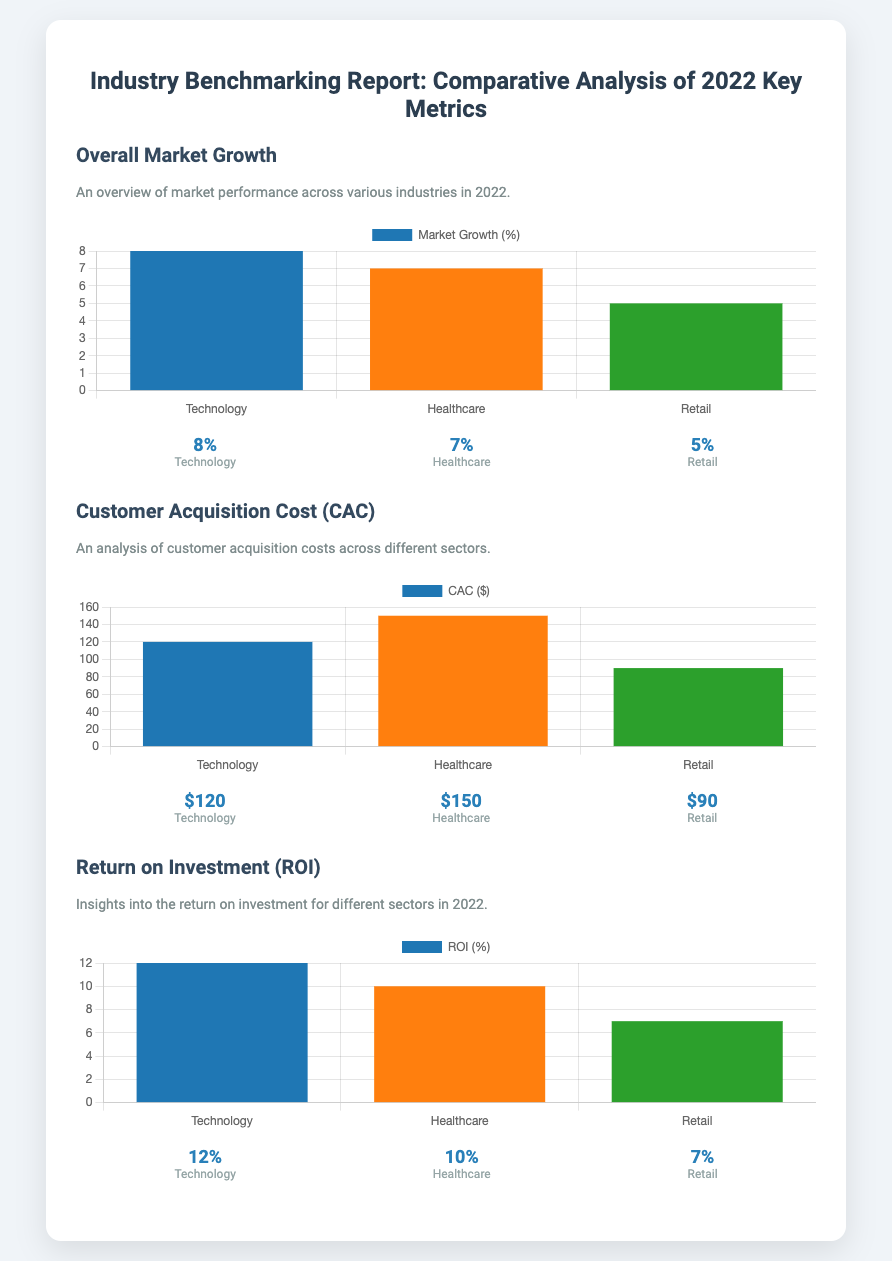What is the market growth percentage for Technology? The market growth percentage for Technology is specified in the document as 8%.
Answer: 8% What is the Customer Acquisition Cost for Healthcare? The Customer Acquisition Cost (CAC) for Healthcare is presented as $150 in the document.
Answer: $150 Which sector has the highest ROI percentage? The document indicates that Technology has the highest ROI percentage, which is 12%.
Answer: Technology What is the market growth percentage for Retail? The market growth percentage for Retail is listed as 5% in the report.
Answer: 5% What is the average CAC across the sectors presented? The average CAC is the mean of the values provided for Technology, Healthcare, and Retail, which calculates to ($120 + $150 + $90) / 3 = $120.
Answer: $120 What sector has the lowest market growth? The document states that Retail has the lowest market growth at 5%.
Answer: Retail What is the ROI percentage for Healthcare? The ROI percentage for Healthcare is mentioned as 10% in the document.
Answer: 10% How many sectors are analyzed in the report? The report analyzes three sectors: Technology, Healthcare, and Retail, as indicated by the charts.
Answer: Three 